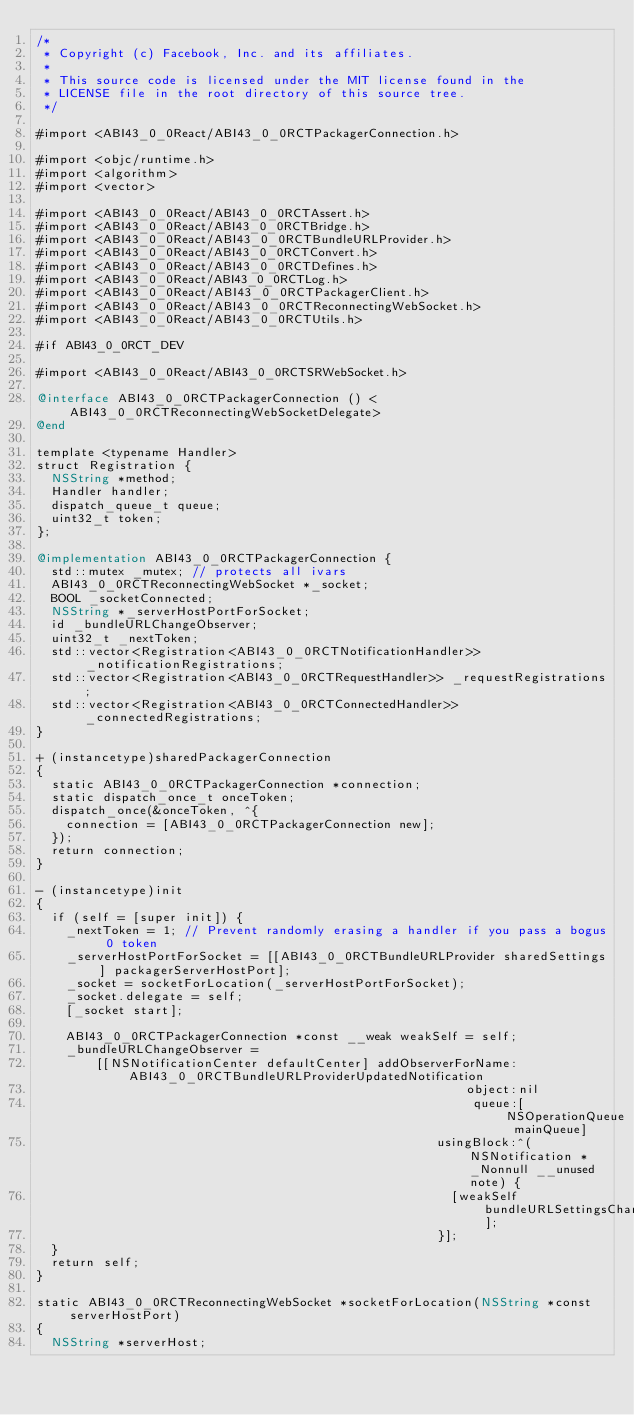Convert code to text. <code><loc_0><loc_0><loc_500><loc_500><_ObjectiveC_>/*
 * Copyright (c) Facebook, Inc. and its affiliates.
 *
 * This source code is licensed under the MIT license found in the
 * LICENSE file in the root directory of this source tree.
 */

#import <ABI43_0_0React/ABI43_0_0RCTPackagerConnection.h>

#import <objc/runtime.h>
#import <algorithm>
#import <vector>

#import <ABI43_0_0React/ABI43_0_0RCTAssert.h>
#import <ABI43_0_0React/ABI43_0_0RCTBridge.h>
#import <ABI43_0_0React/ABI43_0_0RCTBundleURLProvider.h>
#import <ABI43_0_0React/ABI43_0_0RCTConvert.h>
#import <ABI43_0_0React/ABI43_0_0RCTDefines.h>
#import <ABI43_0_0React/ABI43_0_0RCTLog.h>
#import <ABI43_0_0React/ABI43_0_0RCTPackagerClient.h>
#import <ABI43_0_0React/ABI43_0_0RCTReconnectingWebSocket.h>
#import <ABI43_0_0React/ABI43_0_0RCTUtils.h>

#if ABI43_0_0RCT_DEV

#import <ABI43_0_0React/ABI43_0_0RCTSRWebSocket.h>

@interface ABI43_0_0RCTPackagerConnection () <ABI43_0_0RCTReconnectingWebSocketDelegate>
@end

template <typename Handler>
struct Registration {
  NSString *method;
  Handler handler;
  dispatch_queue_t queue;
  uint32_t token;
};

@implementation ABI43_0_0RCTPackagerConnection {
  std::mutex _mutex; // protects all ivars
  ABI43_0_0RCTReconnectingWebSocket *_socket;
  BOOL _socketConnected;
  NSString *_serverHostPortForSocket;
  id _bundleURLChangeObserver;
  uint32_t _nextToken;
  std::vector<Registration<ABI43_0_0RCTNotificationHandler>> _notificationRegistrations;
  std::vector<Registration<ABI43_0_0RCTRequestHandler>> _requestRegistrations;
  std::vector<Registration<ABI43_0_0RCTConnectedHandler>> _connectedRegistrations;
}

+ (instancetype)sharedPackagerConnection
{
  static ABI43_0_0RCTPackagerConnection *connection;
  static dispatch_once_t onceToken;
  dispatch_once(&onceToken, ^{
    connection = [ABI43_0_0RCTPackagerConnection new];
  });
  return connection;
}

- (instancetype)init
{
  if (self = [super init]) {
    _nextToken = 1; // Prevent randomly erasing a handler if you pass a bogus 0 token
    _serverHostPortForSocket = [[ABI43_0_0RCTBundleURLProvider sharedSettings] packagerServerHostPort];
    _socket = socketForLocation(_serverHostPortForSocket);
    _socket.delegate = self;
    [_socket start];

    ABI43_0_0RCTPackagerConnection *const __weak weakSelf = self;
    _bundleURLChangeObserver =
        [[NSNotificationCenter defaultCenter] addObserverForName:ABI43_0_0RCTBundleURLProviderUpdatedNotification
                                                          object:nil
                                                           queue:[NSOperationQueue mainQueue]
                                                      usingBlock:^(NSNotification *_Nonnull __unused note) {
                                                        [weakSelf bundleURLSettingsChanged];
                                                      }];
  }
  return self;
}

static ABI43_0_0RCTReconnectingWebSocket *socketForLocation(NSString *const serverHostPort)
{
  NSString *serverHost;</code> 